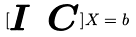Convert formula to latex. <formula><loc_0><loc_0><loc_500><loc_500>[ \begin{matrix} I & C \end{matrix} ] X = b</formula> 